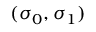<formula> <loc_0><loc_0><loc_500><loc_500>( \sigma _ { 0 } , \sigma _ { 1 } )</formula> 